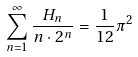Convert formula to latex. <formula><loc_0><loc_0><loc_500><loc_500>\sum _ { n = 1 } ^ { \infty } \frac { H _ { n } } { n \cdot 2 ^ { n } } = \frac { 1 } { 1 2 } \pi ^ { 2 }</formula> 